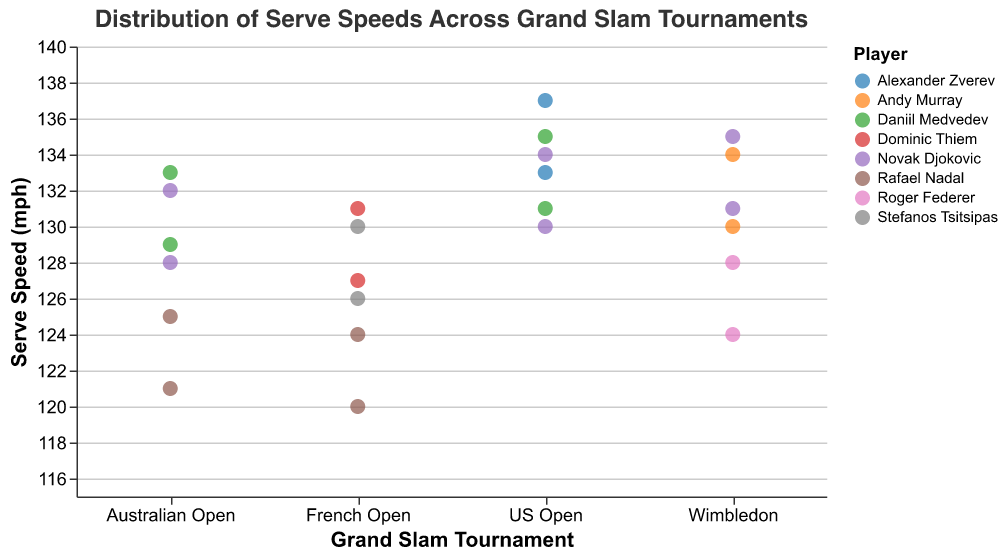What is the title of the figure? The title is located above the strip plot and is clearly displayed at the top. It provides an overview of what the plot represents.
Answer: Distribution of Serve Speeds Across Grand Slam Tournaments Which player has the highest serve speed at the US Open? Look for the data points labeled "US Open" and then identify the player with the highest data point within this category.
Answer: Alexander Zverev What range of serve speeds does Rafael Nadal display across different tournaments? Identify all data points associated with Rafael Nadal and observe their positions along the y-axis to determine the minimum and maximum serve speeds. Rafael Nadal's serve speeds range from 120 mph to 125 mph in the Australian Open and from 120 mph to 124 mph in the French Open.
Answer: 120 mph to 125 mph Which tournament shows the highest variation in serve speeds? Variation can be judged by observing the spread of the data points within each tournament category along the y-axis.
Answer: US Open Compare the median serve speeds of Novak Djokovic at the Australian Open and Wimbledon. To find the median, identify the middle values of Novak Djokovic's serve speeds at both tournaments. For Australian Open, it's between 128 mph and 132 mph, so median is 130 mph. For Wimbledon, it's between 131 mph and 135 mph, so median is 133 mph.
Answer: Australian Open: 130 mph, Wimbledon: 133 mph How does Stefanos Tsitsipas's serve speed at the French Open compare to Rafael Nadal's serve speed at the same tournament? Compare the data points for Stefanos Tsitsipas and Rafael Nadal specific to the French Open. Stefanos Tsitsipas has serve speeds of 126 mph and 130 mph, while Rafael Nadal has serve speeds of 120 mph and 124 mph.
Answer: Stefanos Tsitsipas's serve speeds are higher What is the minimum and maximum serve speed displayed in the plot? Observe the lowest and highest points on the y-axis across all data points. The minimum serve speed is by Rafael Nadal at the French Open (120 mph), and the maximum is by Alexander Zverev at the US Open (137 mph).
Answer: 120 mph and 137 mph Which player shows the most consistent serve speed across different tournaments? Consistency can be identified by observing the players whose data points don't vary much within each tournament. Rafael Nadal and Roger Federer have smaller ranges of serve speeds, indicating more consistency.
Answer: Rafael Nadal What is the average serve speed of Daniil Medvedev across all tournaments? Add up all serve speeds for Daniil Medvedev and divide by the number of his data points. His serve speeds are 129, 133, 131, and 135 mph. Sum is 528 and there are 4 data points. The average is 528/4.
Answer: 132 mph How does the serve speed distribution at the French Open compare to the serve speed distribution at Wimbledon? Observe and compare the spread and range of serve speeds in the French Open and Wimbledon categories. The French Open has a smaller range (120 to 131 mph) compared to Wimbledon (124 to 135 mph), indicating a less varied serve speed distribution at the French Open.
Answer: The French Open has a smaller range and less variation 